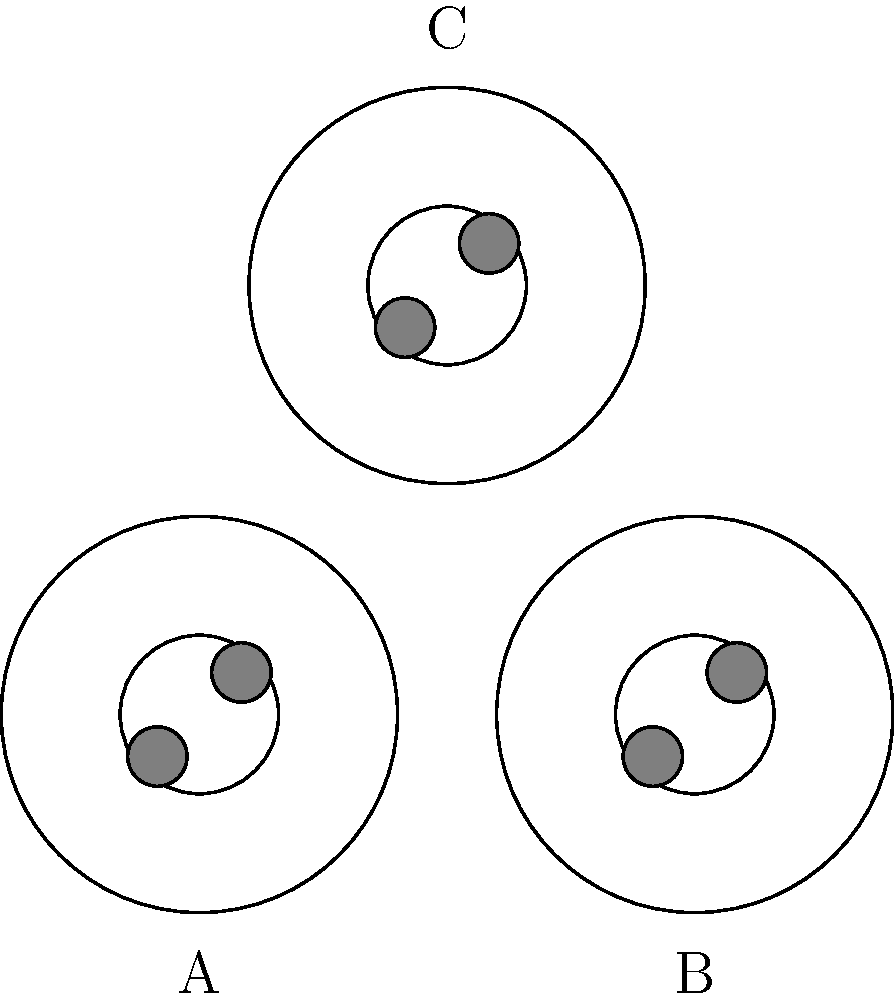In the microscopic images of three different tissue samples (A, B, and C) shown above, which pair of cells exhibits congruent organelle structures? To determine which pair of cells exhibits congruent organelle structures, we need to analyze the internal components of each cell:

1. First, observe that all three cells have a circular outer membrane and a circular nuclear membrane.

2. Inside each cell, there are two smaller circular structures, which could represent organelles such as mitochondria or lysosomes.

3. Comparing the cells:
   a) Cell A: The two organelles are positioned at approximately 45° and 225° angles from the center.
   b) Cell B: The two organelles are positioned at approximately 45° and 225° angles from the center.
   c) Cell C: The two organelles are positioned at approximately 45° and 225° angles from the center.

4. The size and positioning of the organelles in all three cells appear to be identical.

5. However, the question asks for a pair of cells. Since all three cells have the same internal structure, any pair of cells would be considered congruent.

6. Therefore, we can choose any pair of cells as our answer. Let's select cells A and B.
Answer: A and B 